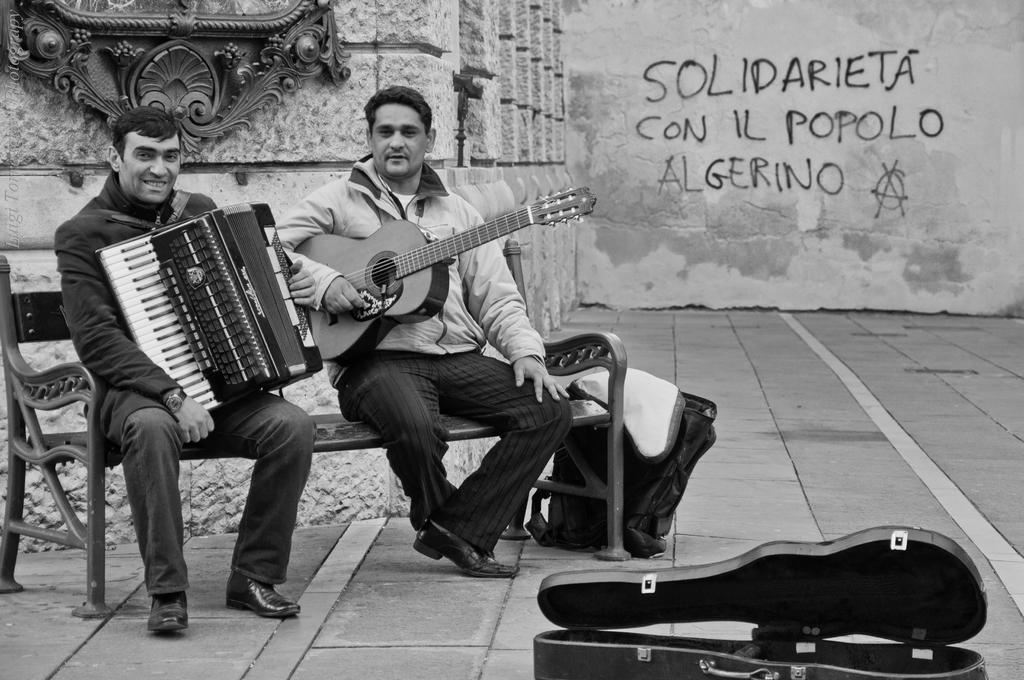How many people are sitting on the bench in the image? There are two persons sitting on a bench in the image. What are the persons holding in their hands? The persons are holding musical instruments. What can be seen on the floor near the bench? There is a bag and a guitar box on the floor. What is present on the wall in the image? There is a frame on the wall. What type of air is being played by the persons in the image? There is no air being played in the image; the persons are holding musical instruments, not air. 